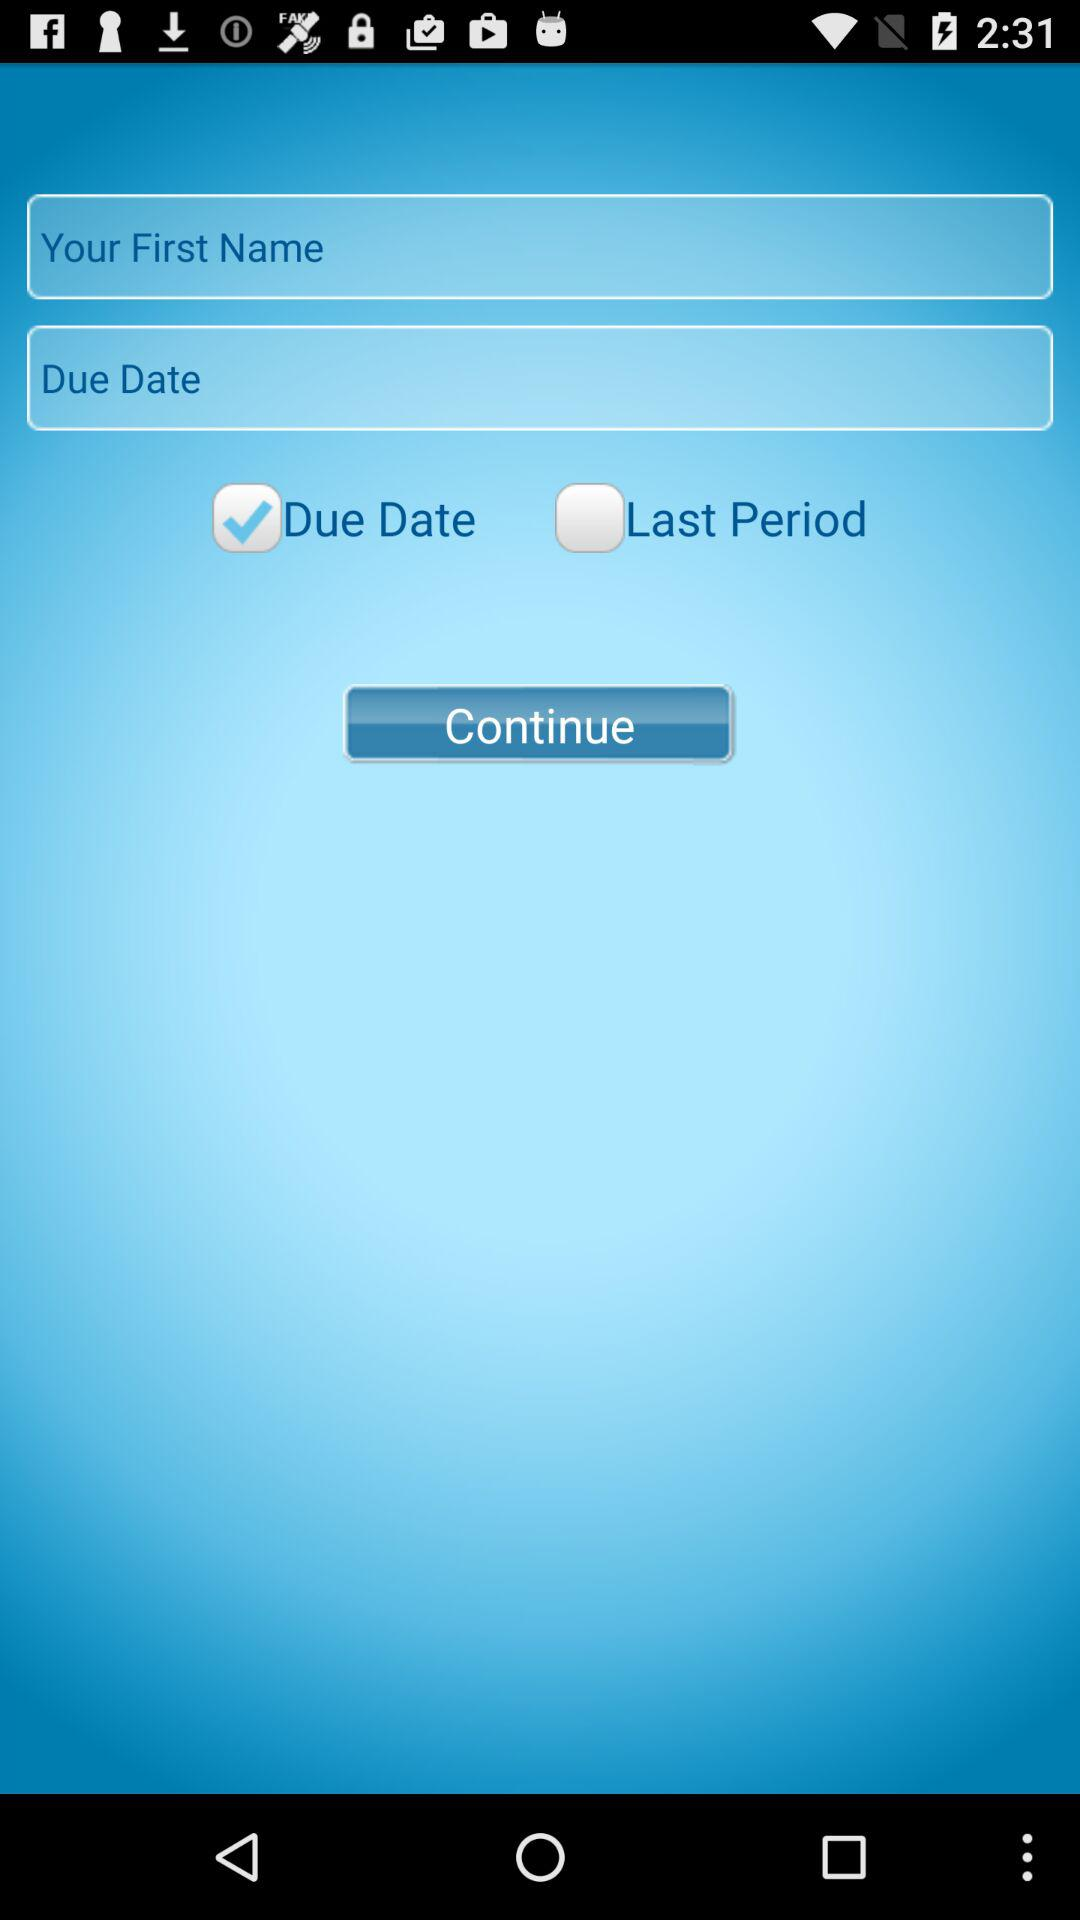Which option has been selected? The selected option is "Due Date". 